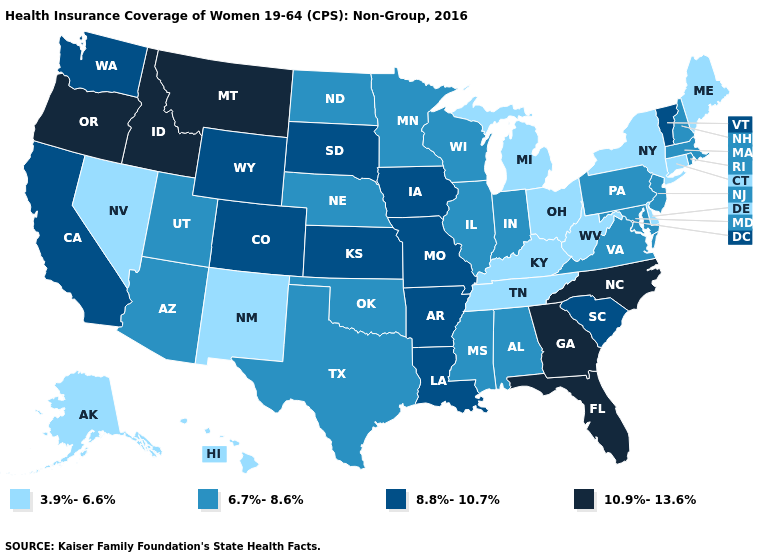Does Utah have a higher value than Nevada?
Give a very brief answer. Yes. Does Alabama have the lowest value in the USA?
Quick response, please. No. What is the lowest value in the West?
Short answer required. 3.9%-6.6%. Which states have the lowest value in the USA?
Keep it brief. Alaska, Connecticut, Delaware, Hawaii, Kentucky, Maine, Michigan, Nevada, New Mexico, New York, Ohio, Tennessee, West Virginia. Name the states that have a value in the range 6.7%-8.6%?
Keep it brief. Alabama, Arizona, Illinois, Indiana, Maryland, Massachusetts, Minnesota, Mississippi, Nebraska, New Hampshire, New Jersey, North Dakota, Oklahoma, Pennsylvania, Rhode Island, Texas, Utah, Virginia, Wisconsin. Among the states that border Maryland , which have the highest value?
Write a very short answer. Pennsylvania, Virginia. What is the value of Ohio?
Give a very brief answer. 3.9%-6.6%. Name the states that have a value in the range 6.7%-8.6%?
Concise answer only. Alabama, Arizona, Illinois, Indiana, Maryland, Massachusetts, Minnesota, Mississippi, Nebraska, New Hampshire, New Jersey, North Dakota, Oklahoma, Pennsylvania, Rhode Island, Texas, Utah, Virginia, Wisconsin. Name the states that have a value in the range 10.9%-13.6%?
Keep it brief. Florida, Georgia, Idaho, Montana, North Carolina, Oregon. What is the lowest value in the USA?
Write a very short answer. 3.9%-6.6%. What is the value of Pennsylvania?
Short answer required. 6.7%-8.6%. Does the map have missing data?
Answer briefly. No. What is the value of New Jersey?
Short answer required. 6.7%-8.6%. What is the value of Montana?
Be succinct. 10.9%-13.6%. What is the value of Ohio?
Short answer required. 3.9%-6.6%. 